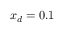<formula> <loc_0><loc_0><loc_500><loc_500>x _ { d } = 0 . 1</formula> 